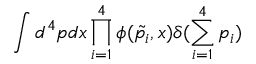Convert formula to latex. <formula><loc_0><loc_0><loc_500><loc_500>\int d ^ { 4 } p d x \prod _ { i = 1 } ^ { 4 } \phi ( \tilde { p _ { i } } , x ) \delta ( \sum _ { i = 1 } ^ { 4 } p _ { i } )</formula> 